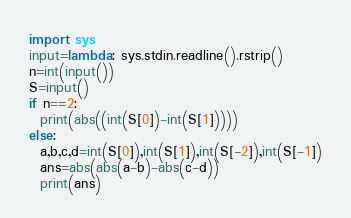Convert code to text. <code><loc_0><loc_0><loc_500><loc_500><_Python_>import sys
input=lambda: sys.stdin.readline().rstrip()
n=int(input())
S=input()
if n==2:
  print(abs((int(S[0])-int(S[1]))))
else:
  a,b,c,d=int(S[0]),int(S[1]),int(S[-2]),int(S[-1])
  ans=abs(abs(a-b)-abs(c-d))
  print(ans)</code> 